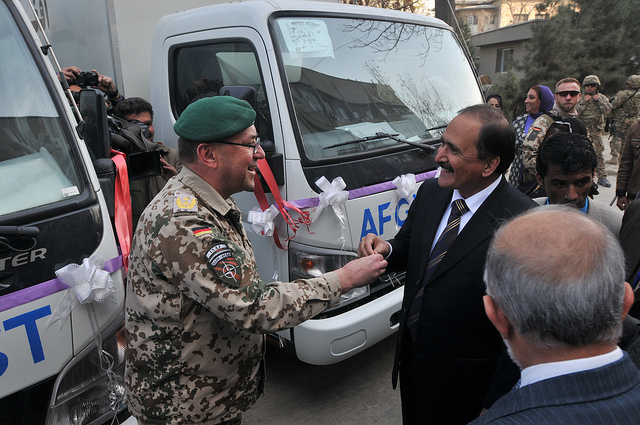Identify the text displayed in this image. AFG TER T 